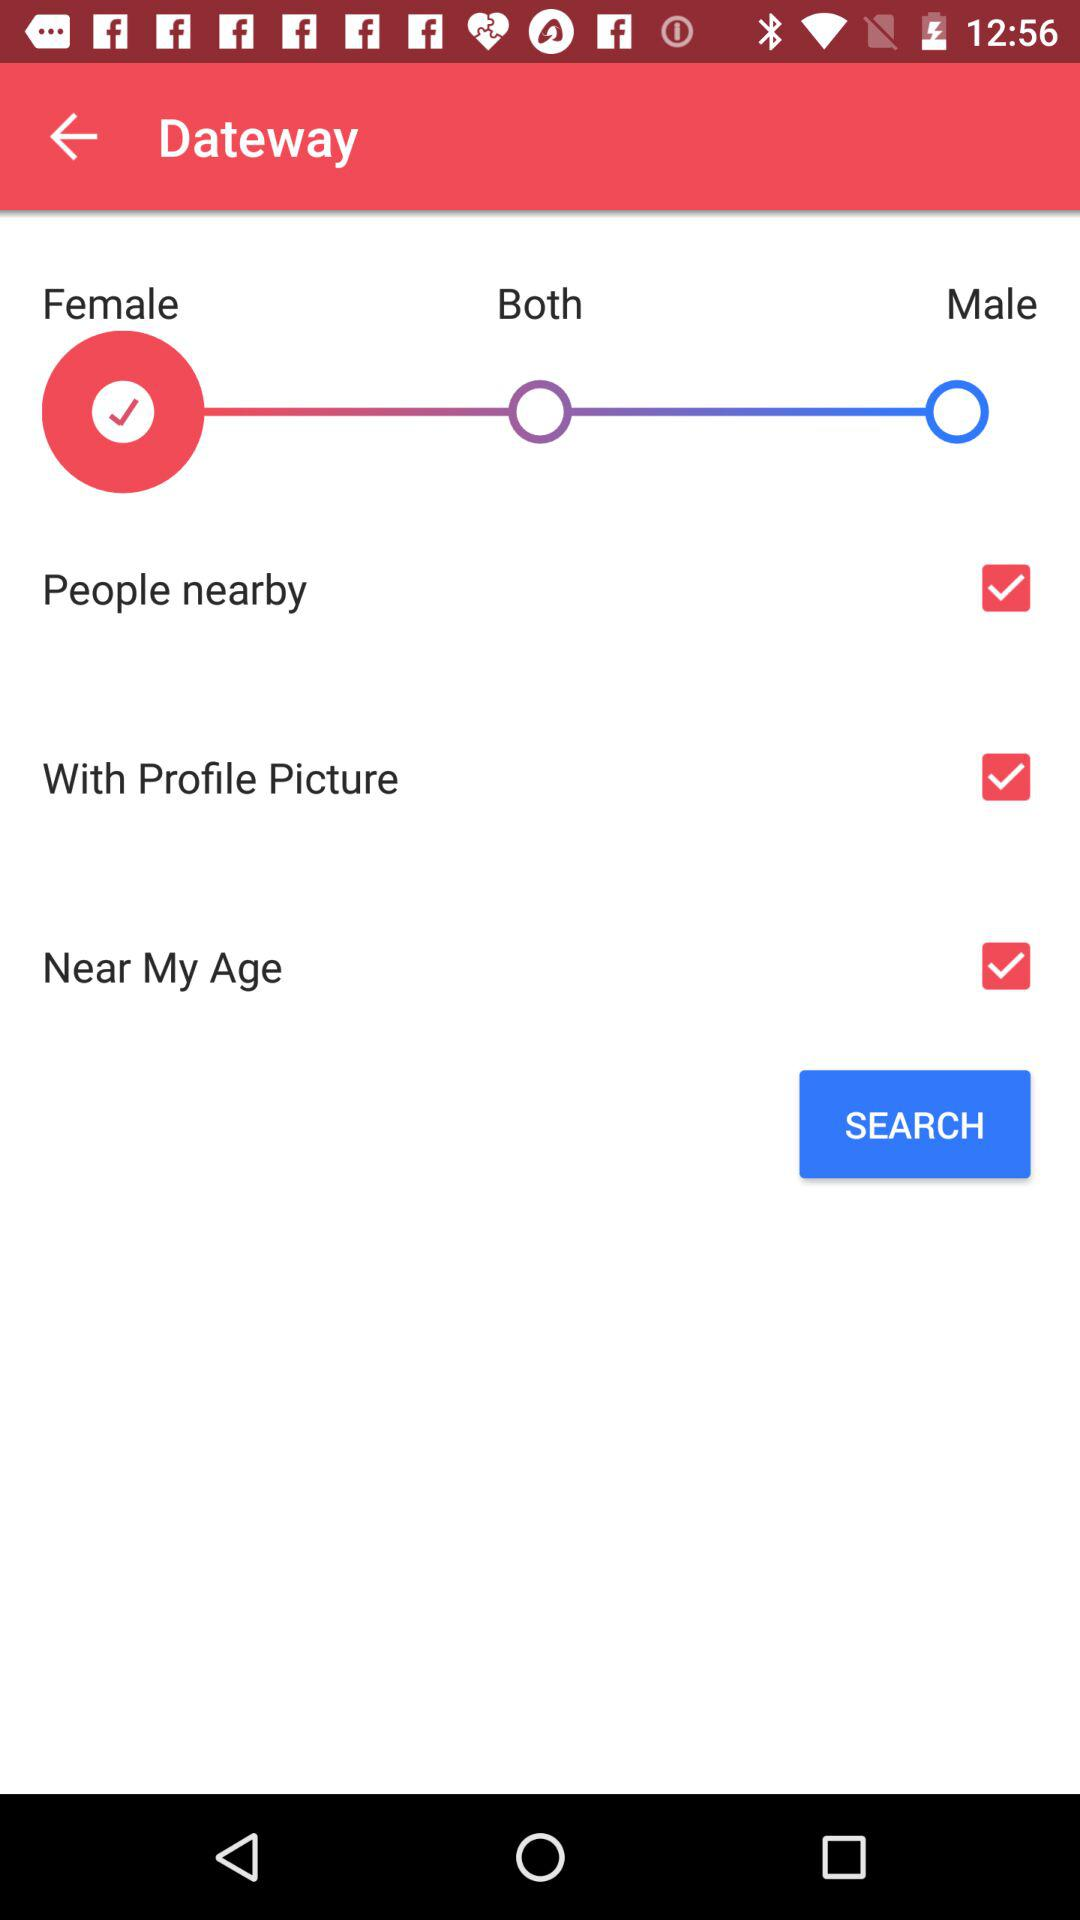Is "People nearby" checked or not? "People nearby" is checked. 